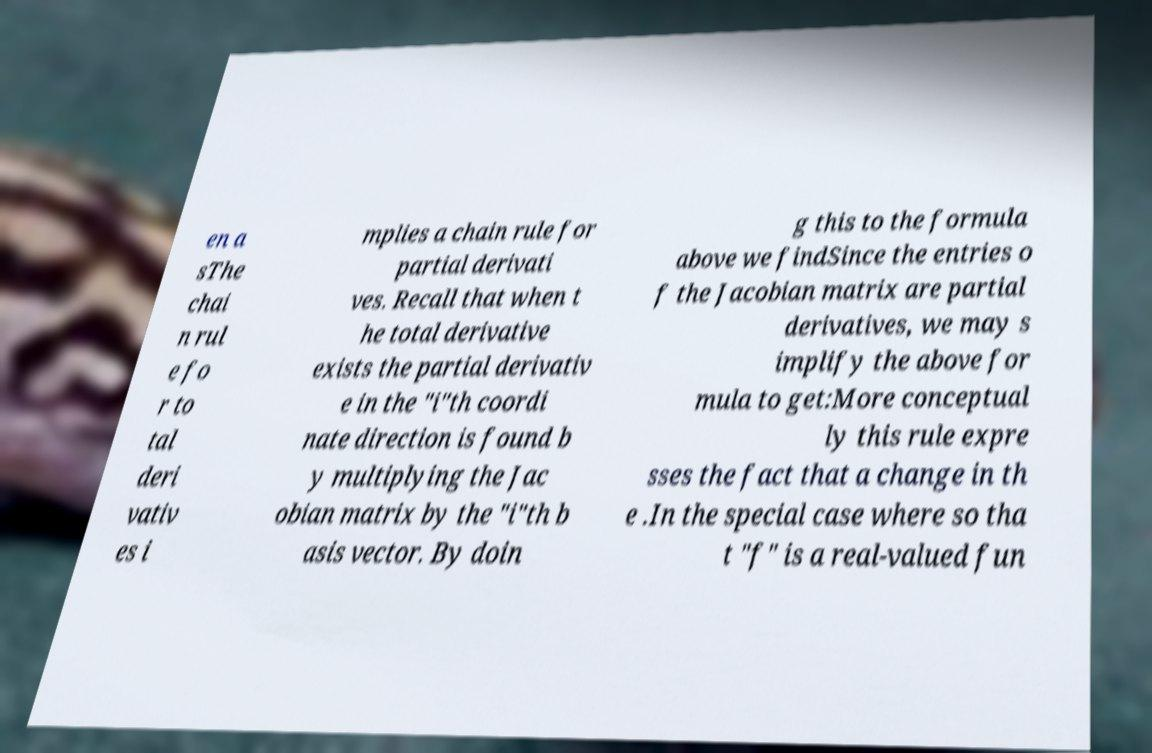What messages or text are displayed in this image? I need them in a readable, typed format. en a sThe chai n rul e fo r to tal deri vativ es i mplies a chain rule for partial derivati ves. Recall that when t he total derivative exists the partial derivativ e in the "i"th coordi nate direction is found b y multiplying the Jac obian matrix by the "i"th b asis vector. By doin g this to the formula above we findSince the entries o f the Jacobian matrix are partial derivatives, we may s implify the above for mula to get:More conceptual ly this rule expre sses the fact that a change in th e .In the special case where so tha t "f" is a real-valued fun 